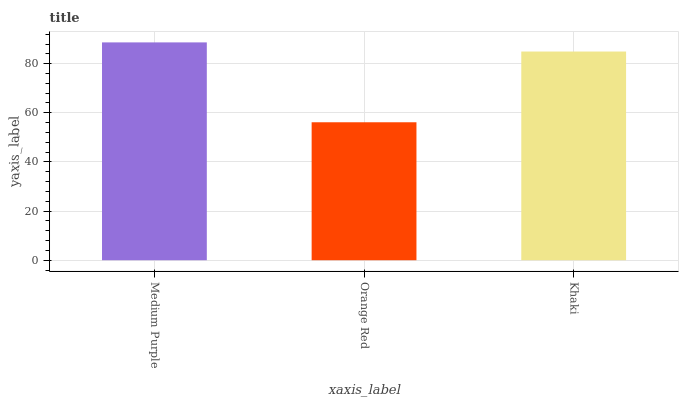Is Orange Red the minimum?
Answer yes or no. Yes. Is Medium Purple the maximum?
Answer yes or no. Yes. Is Khaki the minimum?
Answer yes or no. No. Is Khaki the maximum?
Answer yes or no. No. Is Khaki greater than Orange Red?
Answer yes or no. Yes. Is Orange Red less than Khaki?
Answer yes or no. Yes. Is Orange Red greater than Khaki?
Answer yes or no. No. Is Khaki less than Orange Red?
Answer yes or no. No. Is Khaki the high median?
Answer yes or no. Yes. Is Khaki the low median?
Answer yes or no. Yes. Is Medium Purple the high median?
Answer yes or no. No. Is Orange Red the low median?
Answer yes or no. No. 